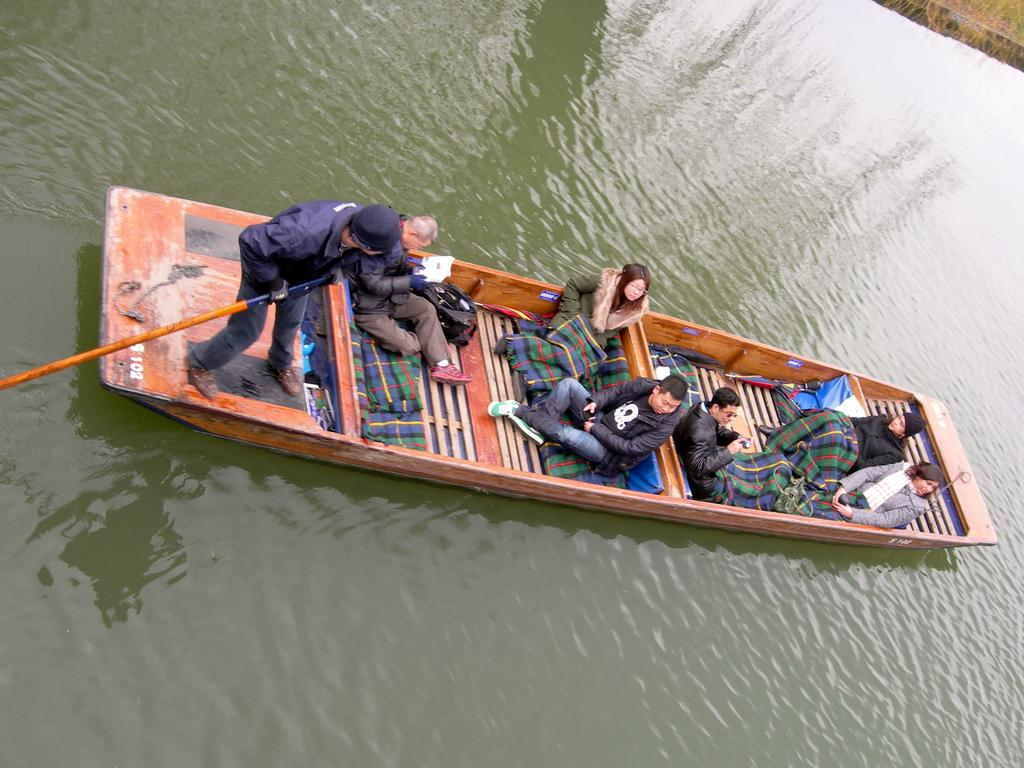What are the people in the image doing? The persons in the image are sitting on a boat in the foreground. What is the man on the boat doing? The man is standing on the boat and holding a paddle. Where is the boat located? The boat is on the water. What can be seen in the right top corner of the image? There is grass visible in the right top corner of the image. What type of treatment is being administered to the boat in the image? There is no treatment being administered to the boat in the image; it is simply floating on the water. Can you tell me how the man is driving the boat in the image? The man is not driving the boat in the image; he is standing on it and holding a paddle, which suggests he is using it for propulsion. 